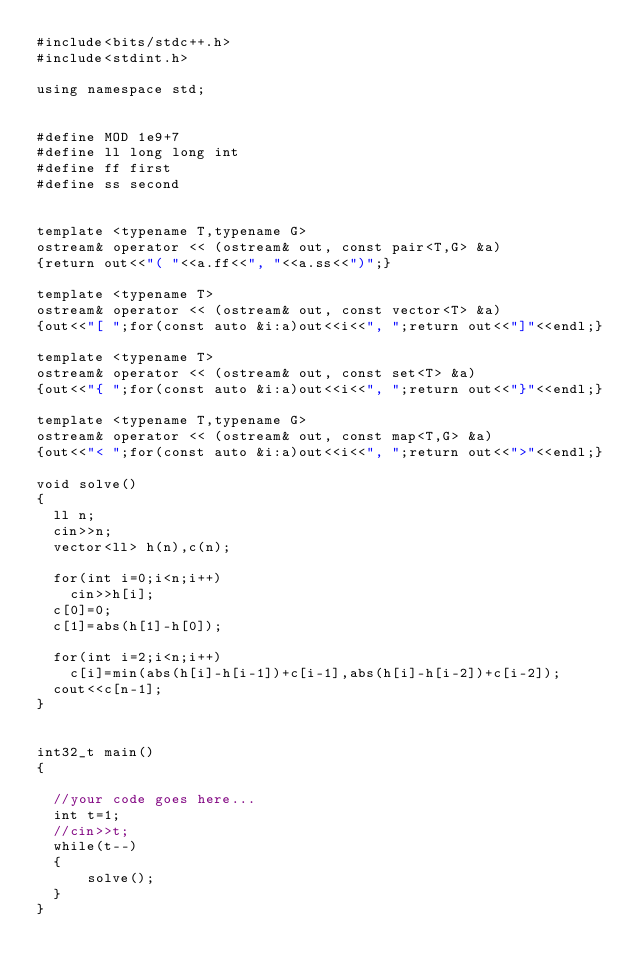Convert code to text. <code><loc_0><loc_0><loc_500><loc_500><_C++_>#include<bits/stdc++.h>
#include<stdint.h>

using namespace std;


#define MOD 1e9+7
#define ll long long int
#define ff first
#define ss second


template <typename T,typename G>
ostream& operator << (ostream& out, const pair<T,G> &a) 
{return out<<"( "<<a.ff<<", "<<a.ss<<")";}

template <typename T>
ostream& operator << (ostream& out, const vector<T> &a) 
{out<<"[ ";for(const auto &i:a)out<<i<<", ";return out<<"]"<<endl;}

template <typename T>
ostream& operator << (ostream& out, const set<T> &a) 
{out<<"{ ";for(const auto &i:a)out<<i<<", ";return out<<"}"<<endl;}

template <typename T,typename G>
ostream& operator << (ostream& out, const map<T,G> &a) 
{out<<"< ";for(const auto &i:a)out<<i<<", ";return out<<">"<<endl;}

void solve()
{
	ll n;
	cin>>n;
	vector<ll> h(n),c(n);

	for(int i=0;i<n;i++)
		cin>>h[i];
	c[0]=0;
	c[1]=abs(h[1]-h[0]);

	for(int i=2;i<n;i++)
		c[i]=min(abs(h[i]-h[i-1])+c[i-1],abs(h[i]-h[i-2])+c[i-2]);
	cout<<c[n-1];
}


int32_t main()
{
	
	//your code goes here...	
	int t=1;
	//cin>>t;
	while(t--)
	{
	    solve();
	}	
}</code> 